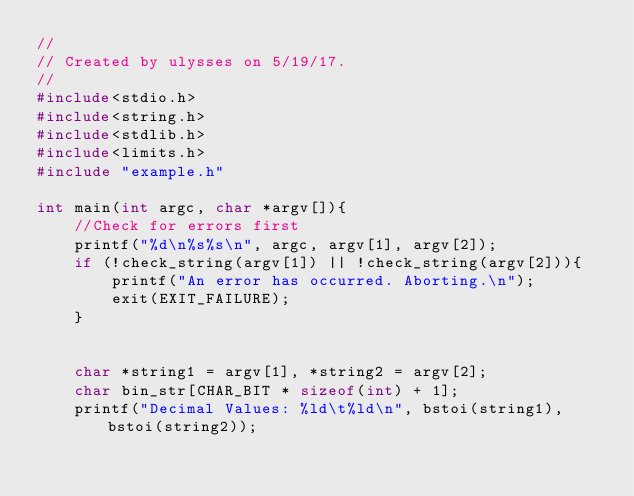<code> <loc_0><loc_0><loc_500><loc_500><_C_>//
// Created by ulysses on 5/19/17.
//
#include<stdio.h>
#include<string.h>
#include<stdlib.h>
#include<limits.h>
#include "example.h"

int main(int argc, char *argv[]){
    //Check for errors first
    printf("%d\n%s%s\n", argc, argv[1], argv[2]);
    if (!check_string(argv[1]) || !check_string(argv[2])){
        printf("An error has occurred. Aborting.\n");
        exit(EXIT_FAILURE);
    }


    char *string1 = argv[1], *string2 = argv[2];
    char bin_str[CHAR_BIT * sizeof(int) + 1];
    printf("Decimal Values: %ld\t%ld\n", bstoi(string1), bstoi(string2));</code> 